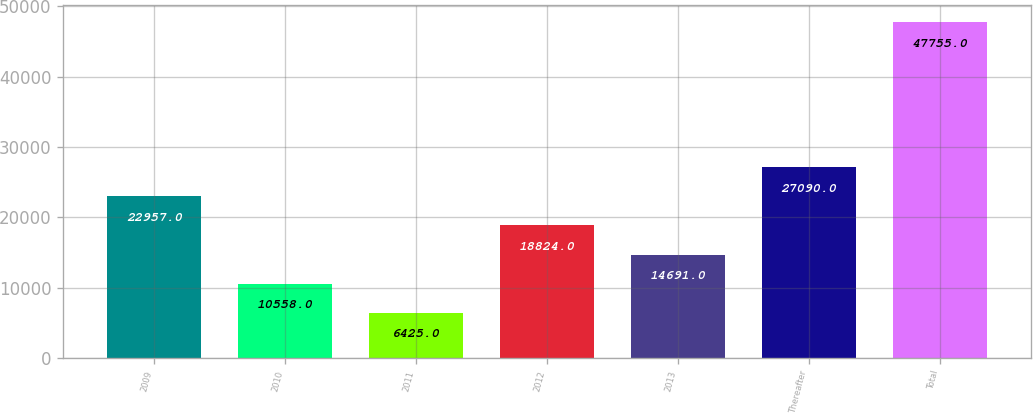Convert chart to OTSL. <chart><loc_0><loc_0><loc_500><loc_500><bar_chart><fcel>2009<fcel>2010<fcel>2011<fcel>2012<fcel>2013<fcel>Thereafter<fcel>Total<nl><fcel>22957<fcel>10558<fcel>6425<fcel>18824<fcel>14691<fcel>27090<fcel>47755<nl></chart> 